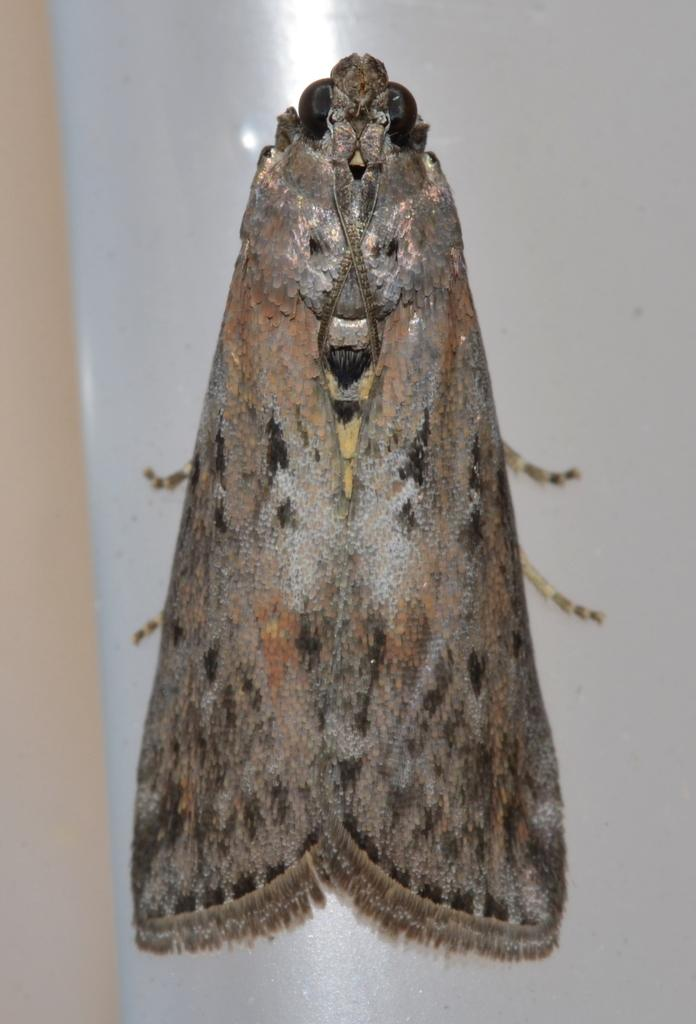What type of creature is present in the image? There is an insect in the image. Can you identify the specific type of insect? The insect is a brown house moth. What is the background or surface that the insect is on? The insect is on a white color object. What type of mine can be seen in the image? There is no mine present in the image; it features an insect on a white color object. Can you describe the roof of the building in the image? There is no building or roof present in the image; it features an insect on a white color object. 